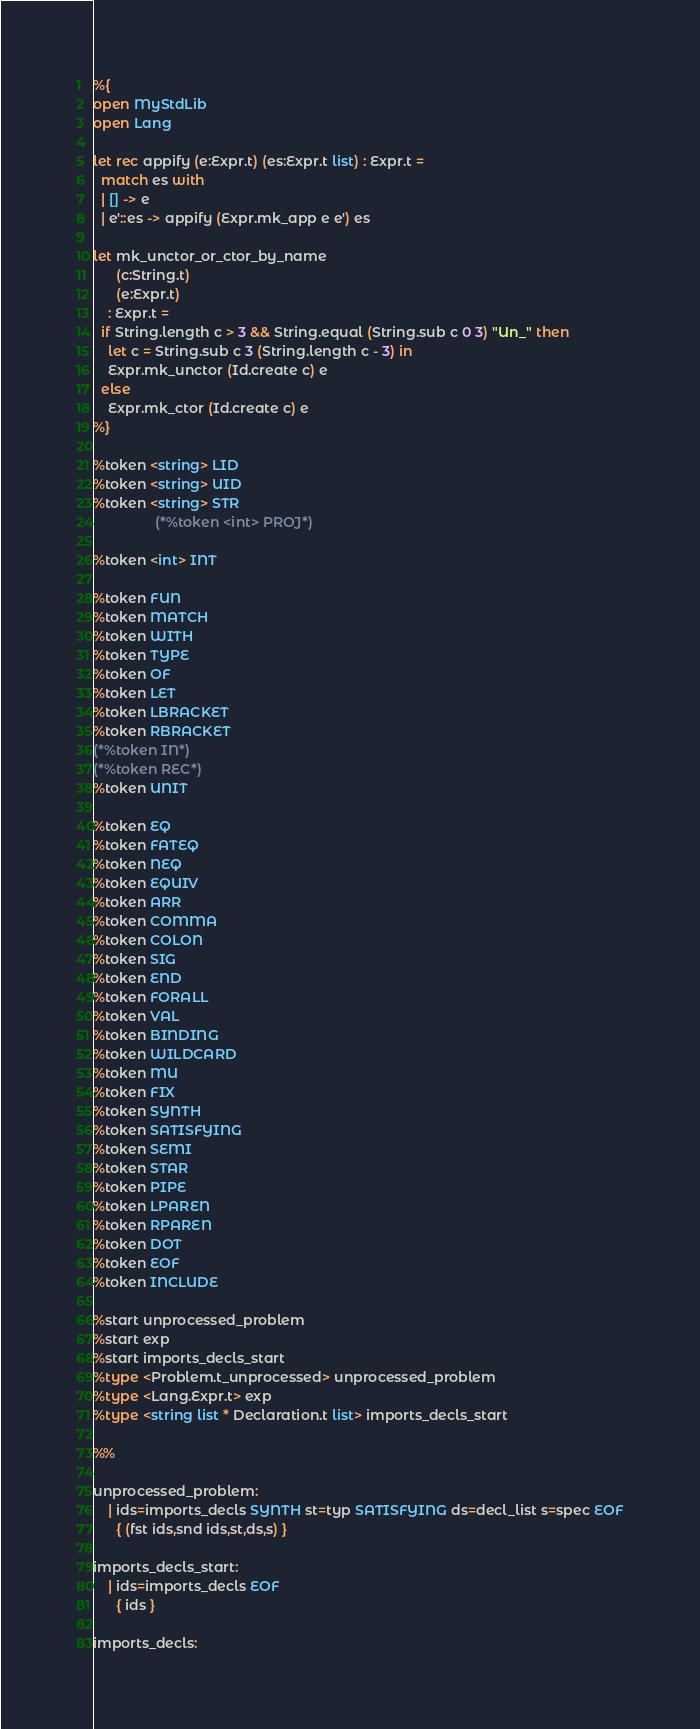<code> <loc_0><loc_0><loc_500><loc_500><_OCaml_>%{
open MyStdLib
open Lang

let rec appify (e:Expr.t) (es:Expr.t list) : Expr.t =
  match es with
  | [] -> e
  | e'::es -> appify (Expr.mk_app e e') es

let mk_unctor_or_ctor_by_name
      (c:String.t)
      (e:Expr.t)
    : Expr.t =
  if String.length c > 3 && String.equal (String.sub c 0 3) "Un_" then
    let c = String.sub c 3 (String.length c - 3) in
    Expr.mk_unctor (Id.create c) e
  else
    Expr.mk_ctor (Id.create c) e
%}

%token <string> LID
%token <string> UID
%token <string> STR
                (*%token <int> PROJ*)

%token <int> INT

%token FUN
%token MATCH
%token WITH
%token TYPE
%token OF
%token LET
%token LBRACKET
%token RBRACKET
(*%token IN*)
(*%token REC*)
%token UNIT

%token EQ
%token FATEQ
%token NEQ
%token EQUIV
%token ARR
%token COMMA
%token COLON
%token SIG
%token END
%token FORALL
%token VAL
%token BINDING
%token WILDCARD
%token MU
%token FIX
%token SYNTH
%token SATISFYING
%token SEMI
%token STAR
%token PIPE
%token LPAREN
%token RPAREN
%token DOT
%token EOF
%token INCLUDE

%start unprocessed_problem
%start exp
%start imports_decls_start
%type <Problem.t_unprocessed> unprocessed_problem
%type <Lang.Expr.t> exp
%type <string list * Declaration.t list> imports_decls_start

%%

unprocessed_problem:
    | ids=imports_decls SYNTH st=typ SATISFYING ds=decl_list s=spec EOF
      { (fst ids,snd ids,st,ds,s) }

imports_decls_start:
    | ids=imports_decls EOF
      { ids }

imports_decls:</code> 